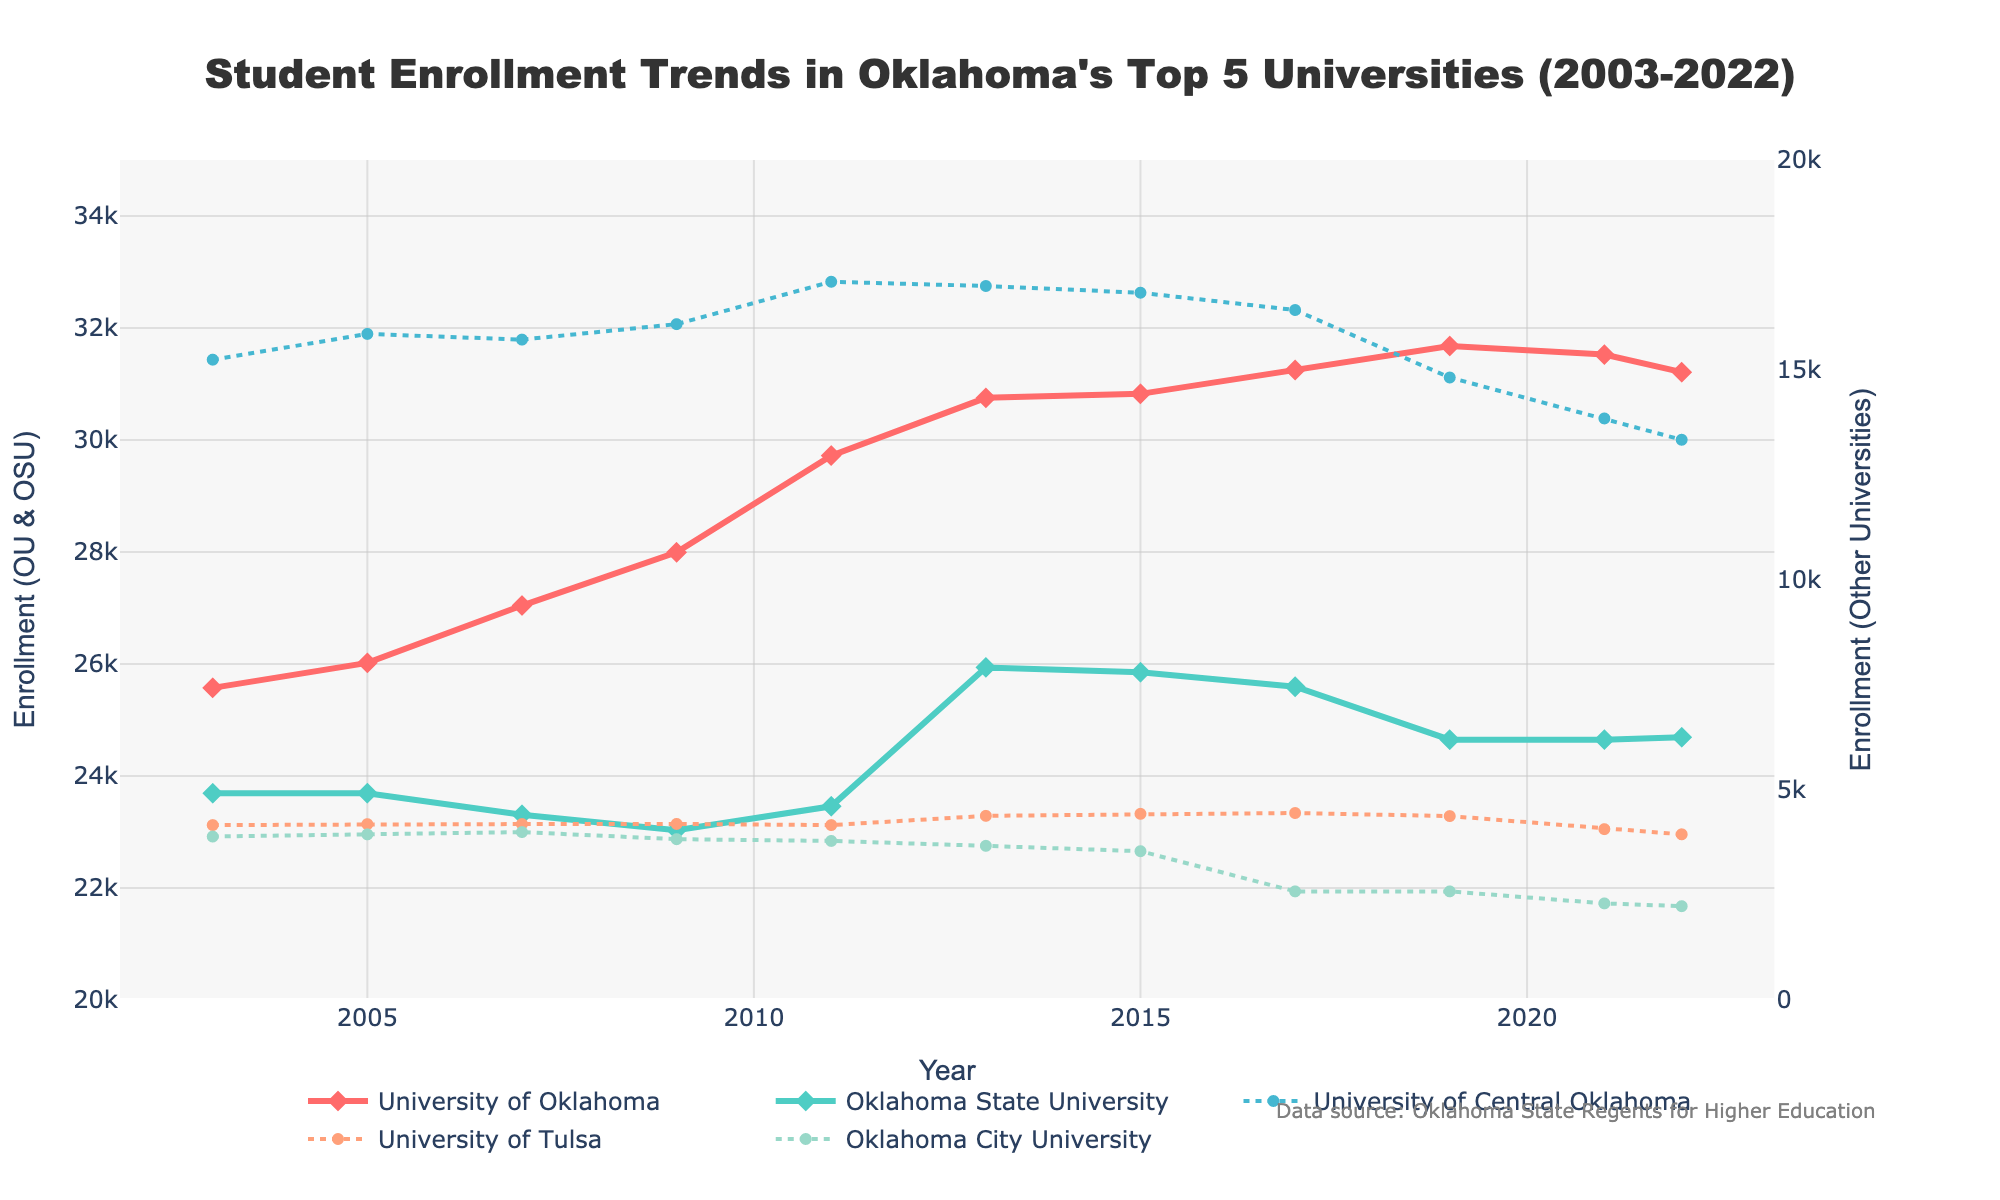What year did the University of Oklahoma have its highest enrollment? Look at the line corresponding to the University of Oklahoma and identify the peak point on the chart. The highest value is around 31,000, which occurs in 2019.
Answer: 2019 Which university had a decrease in enrollment from 2019 to 2022? Compare the endpoints of the lines for each university from 2019 to 2022. The University of Central Oklahoma, University of Tulsa, and Oklahoma City University all show a decrease in enrollment during this period.
Answer: University of Central Oklahoma, University of Tulsa, Oklahoma City University How many universities had an enrollment higher than 25,000 in 2022? Examine the y-axis and check which lines are above the 25,000 mark in the year 2022. Both the University of Oklahoma and Oklahoma State University have enrollments higher than 25,000 in 2022.
Answer: 2 What is the enrollment trend for Oklahoma City University from 2003 to 2022? Follow the line corresponding to Oklahoma City University and observe the direction it takes over the years. The trend starts around 3,892 in 2003 and ends at 2,234 in 2022, showing a general decrease.
Answer: Decreasing Did any university show a continuous increase in enrollment over the 20 years? Review each line and check for any that show a consistent upward trend from 2003 to 2022. No university shows a continuous increase; however, the University of Oklahoma shows an overall increasing trend with some fluctuations.
Answer: University of Oklahoma (with fluctuations) What is the difference in enrollment between the University of Central Oklahoma and the University of Tulsa in the year 2013? Look at the enrollment numbers for the University of Central Oklahoma and the University of Tulsa in 2013, then subtract the latter's enrollment from the former's (17,000 - 4,385).
Answer: 12,615 Which university has the smallest enrollment in 2022? Check the endpoints of all the lines for the year 2022 and identify the one with the lowest value. The University with the smallest enrollment in 2022 is Oklahoma City University with 2,234 students.
Answer: Oklahoma City University How did the enrollment at Oklahoma State University change from 2003 to 2022? Follow the line corresponding to Oklahoma State University from 2003 to 2022. Enrollment starts at 23,692 in 2003 and ends at 24,692 in 2022, indicating a generally stable trend with a slight increase.
Answer: Slight increase 